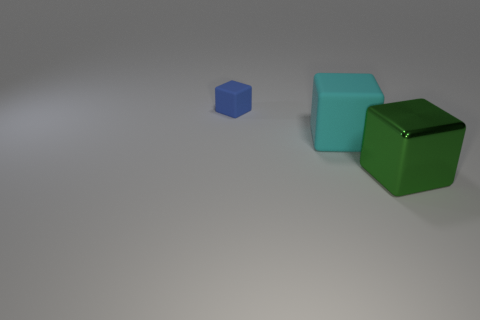Add 1 large brown rubber cylinders. How many objects exist? 4 Add 1 small matte objects. How many small matte objects are left? 2 Add 1 blue blocks. How many blue blocks exist? 2 Subtract 0 brown cubes. How many objects are left? 3 Subtract all cyan cubes. Subtract all big cyan objects. How many objects are left? 1 